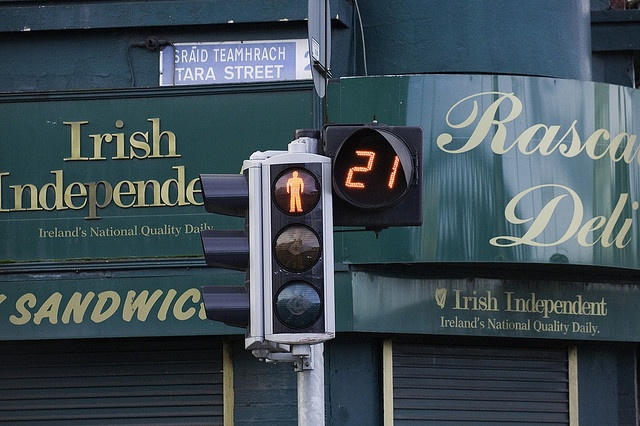Describe the objects in this image and their specific colors. I can see traffic light in darkblue, black, gray, purple, and lightgray tones and traffic light in darkblue, black, gray, and maroon tones in this image. 